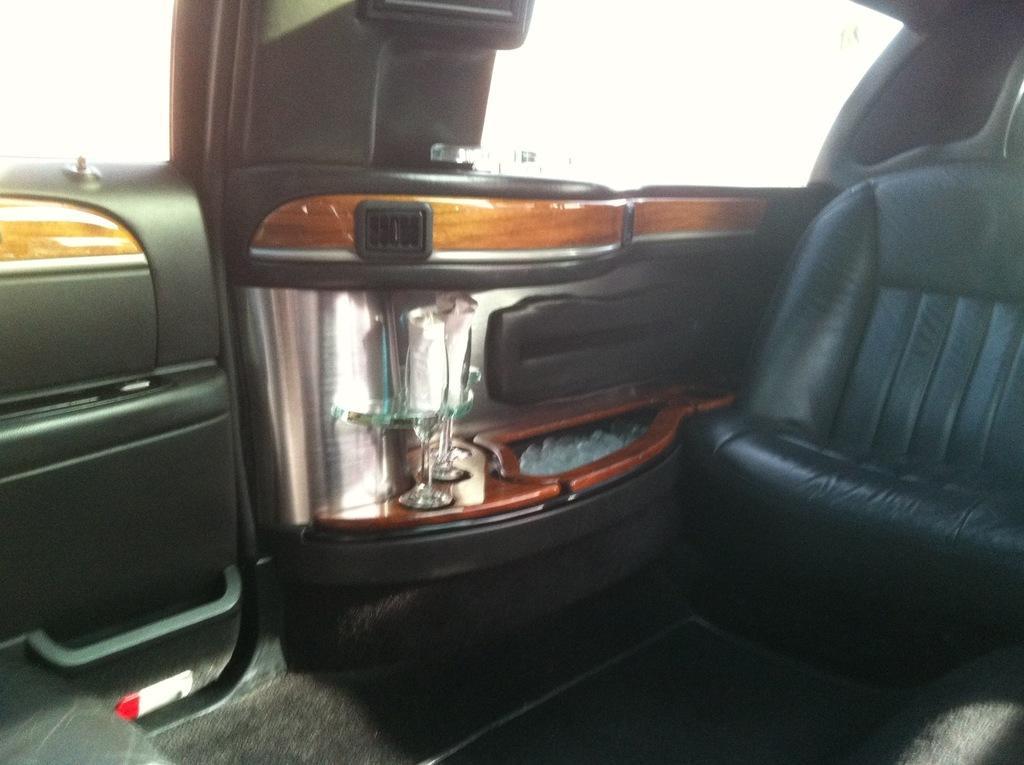Can you describe this image briefly? This is inside view of a vehicle and we can see seat and side doors and there are glasses on the side door platform. 